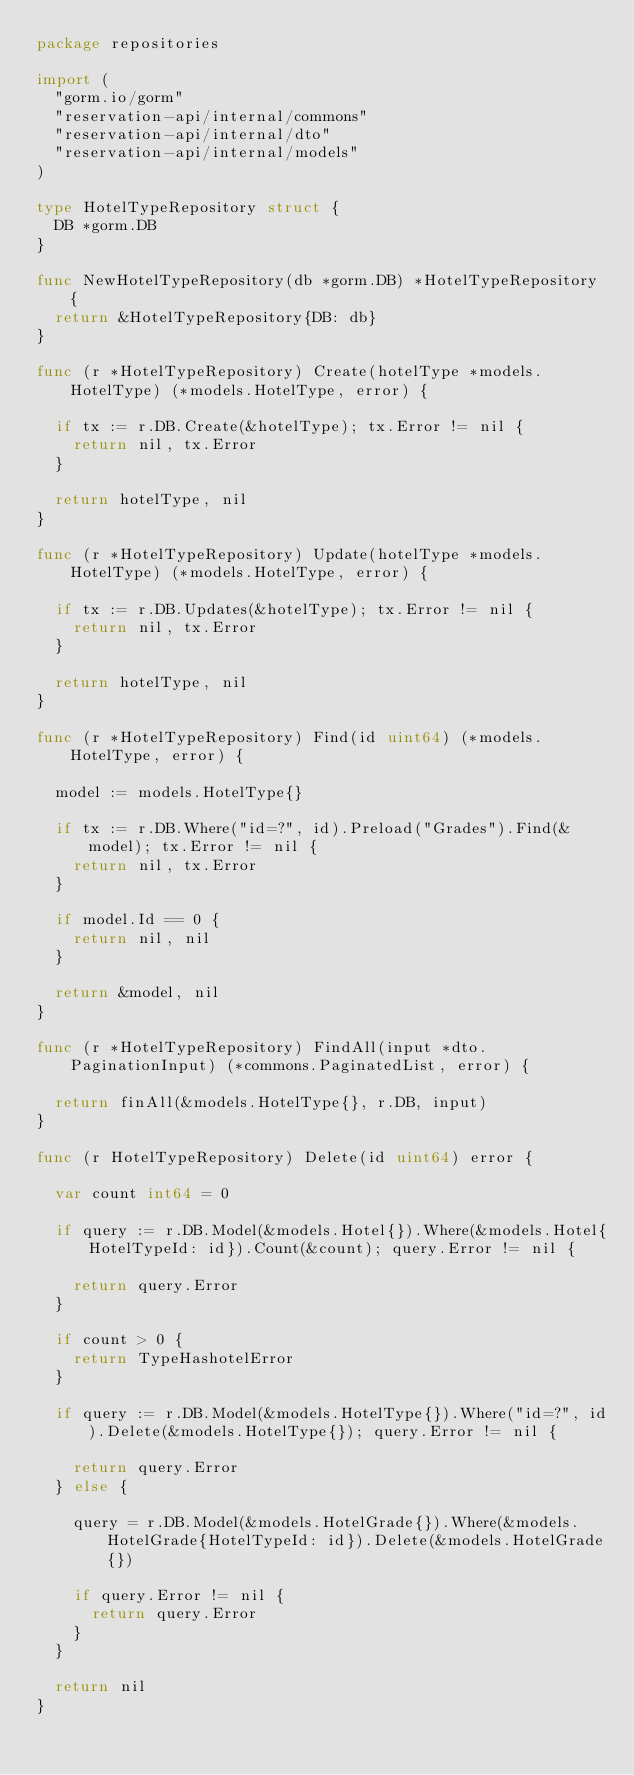<code> <loc_0><loc_0><loc_500><loc_500><_Go_>package repositories

import (
	"gorm.io/gorm"
	"reservation-api/internal/commons"
	"reservation-api/internal/dto"
	"reservation-api/internal/models"
)

type HotelTypeRepository struct {
	DB *gorm.DB
}

func NewHotelTypeRepository(db *gorm.DB) *HotelTypeRepository {
	return &HotelTypeRepository{DB: db}
}

func (r *HotelTypeRepository) Create(hotelType *models.HotelType) (*models.HotelType, error) {

	if tx := r.DB.Create(&hotelType); tx.Error != nil {
		return nil, tx.Error
	}

	return hotelType, nil
}

func (r *HotelTypeRepository) Update(hotelType *models.HotelType) (*models.HotelType, error) {

	if tx := r.DB.Updates(&hotelType); tx.Error != nil {
		return nil, tx.Error
	}

	return hotelType, nil
}

func (r *HotelTypeRepository) Find(id uint64) (*models.HotelType, error) {

	model := models.HotelType{}

	if tx := r.DB.Where("id=?", id).Preload("Grades").Find(&model); tx.Error != nil {
		return nil, tx.Error
	}

	if model.Id == 0 {
		return nil, nil
	}

	return &model, nil
}

func (r *HotelTypeRepository) FindAll(input *dto.PaginationInput) (*commons.PaginatedList, error) {

	return finAll(&models.HotelType{}, r.DB, input)
}

func (r HotelTypeRepository) Delete(id uint64) error {

	var count int64 = 0

	if query := r.DB.Model(&models.Hotel{}).Where(&models.Hotel{HotelTypeId: id}).Count(&count); query.Error != nil {

		return query.Error
	}

	if count > 0 {
		return TypeHashotelError
	}

	if query := r.DB.Model(&models.HotelType{}).Where("id=?", id).Delete(&models.HotelType{}); query.Error != nil {

		return query.Error
	} else {

		query = r.DB.Model(&models.HotelGrade{}).Where(&models.HotelGrade{HotelTypeId: id}).Delete(&models.HotelGrade{})

		if query.Error != nil {
			return query.Error
		}
	}

	return nil
}
</code> 